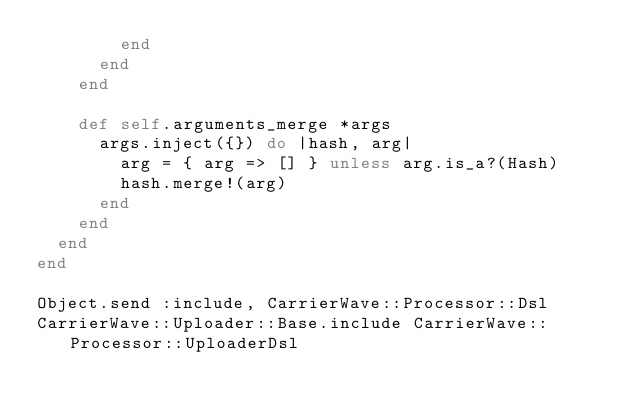<code> <loc_0><loc_0><loc_500><loc_500><_Ruby_>        end
      end
    end

    def self.arguments_merge *args
      args.inject({}) do |hash, arg|
        arg = { arg => [] } unless arg.is_a?(Hash)
        hash.merge!(arg)
      end
    end
  end
end

Object.send :include, CarrierWave::Processor::Dsl
CarrierWave::Uploader::Base.include CarrierWave::Processor::UploaderDsl</code> 